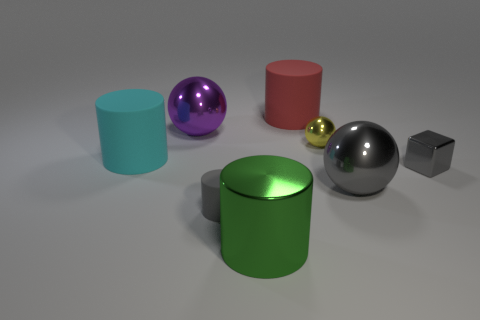Can you tell me the different colors of the objects seen in the image? Certainly! There is a cyan cylinder, a purple sphere, a red cylinder, a yellow sphere, a large grey sphere, and a small grey cube. 